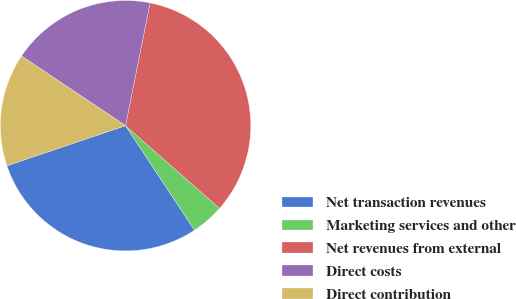Convert chart. <chart><loc_0><loc_0><loc_500><loc_500><pie_chart><fcel>Net transaction revenues<fcel>Marketing services and other<fcel>Net revenues from external<fcel>Direct costs<fcel>Direct contribution<nl><fcel>29.09%<fcel>4.24%<fcel>33.33%<fcel>18.75%<fcel>14.58%<nl></chart> 